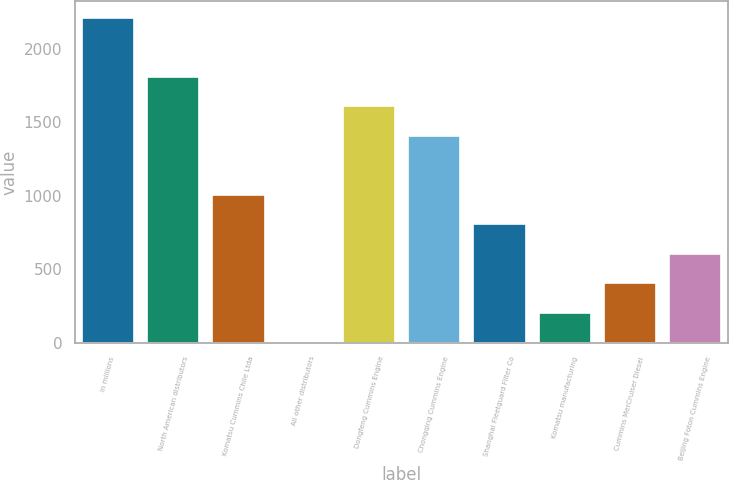<chart> <loc_0><loc_0><loc_500><loc_500><bar_chart><fcel>In millions<fcel>North American distributors<fcel>Komatsu Cummins Chile Ltda<fcel>All other distributors<fcel>Dongfeng Cummins Engine<fcel>Chongqing Cummins Engine<fcel>Shanghai Fleetguard Filter Co<fcel>Komatsu manufacturing<fcel>Cummins MerCruiser Diesel<fcel>Beijing Foton Cummins Engine<nl><fcel>2212<fcel>1810<fcel>1006<fcel>1<fcel>1609<fcel>1408<fcel>805<fcel>202<fcel>403<fcel>604<nl></chart> 